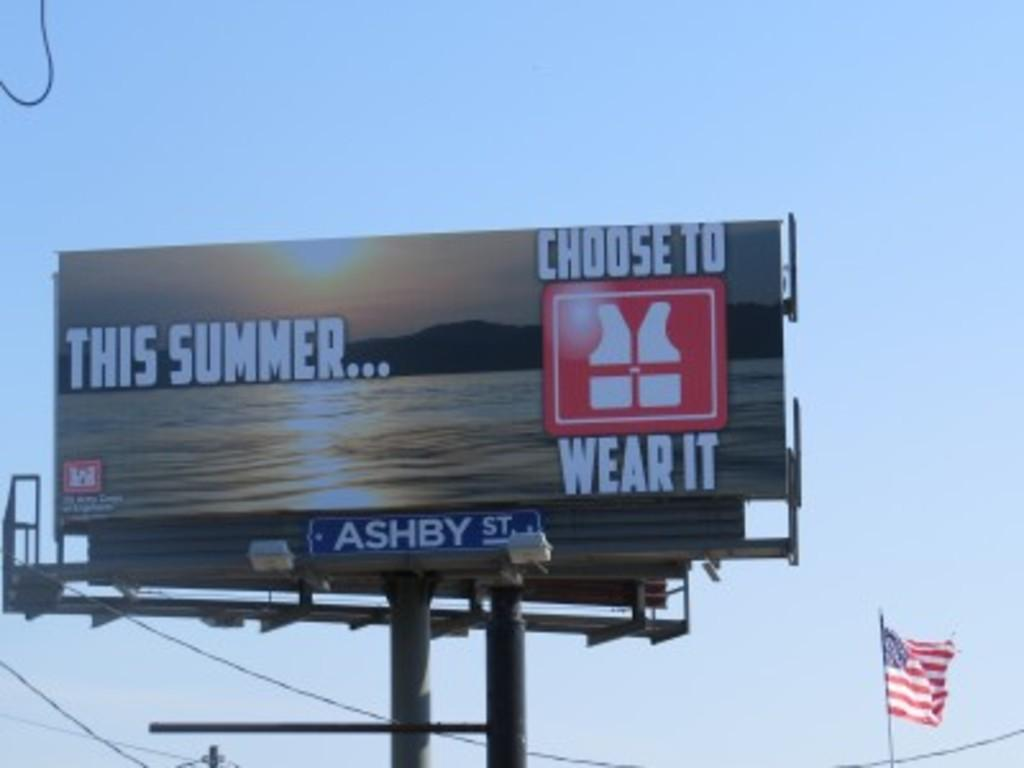<image>
Summarize the visual content of the image. A this summer choose to wear it banner with Ashby Steet sign below it. 